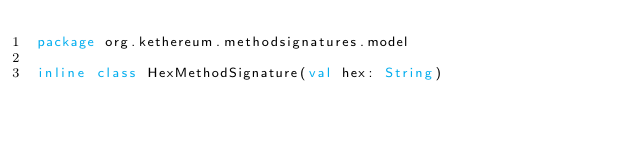<code> <loc_0><loc_0><loc_500><loc_500><_Kotlin_>package org.kethereum.methodsignatures.model

inline class HexMethodSignature(val hex: String)</code> 